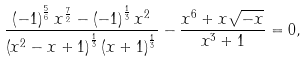<formula> <loc_0><loc_0><loc_500><loc_500>\frac { \left ( - 1 \right ) ^ { \frac { 5 } { 6 } } x ^ { \frac { 7 } { 2 } } - \left ( - 1 \right ) ^ { \frac { 1 } { 3 } } x ^ { 2 } } { \left ( x ^ { 2 } - x + 1 \right ) ^ { \frac { 1 } { 3 } } \left ( x + 1 \right ) ^ { \frac { 1 } { 3 } } } - \frac { x ^ { 6 } + x \sqrt { - x } } { x ^ { 3 } + 1 } = 0 ,</formula> 